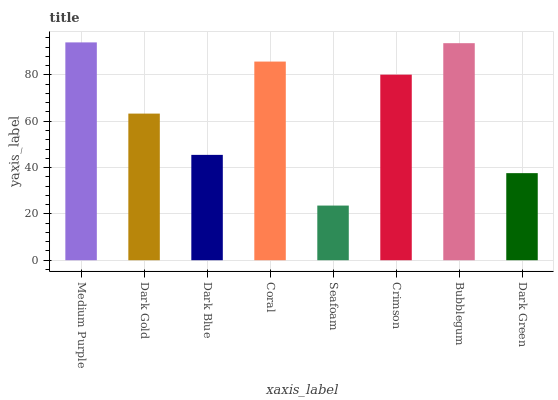Is Seafoam the minimum?
Answer yes or no. Yes. Is Medium Purple the maximum?
Answer yes or no. Yes. Is Dark Gold the minimum?
Answer yes or no. No. Is Dark Gold the maximum?
Answer yes or no. No. Is Medium Purple greater than Dark Gold?
Answer yes or no. Yes. Is Dark Gold less than Medium Purple?
Answer yes or no. Yes. Is Dark Gold greater than Medium Purple?
Answer yes or no. No. Is Medium Purple less than Dark Gold?
Answer yes or no. No. Is Crimson the high median?
Answer yes or no. Yes. Is Dark Gold the low median?
Answer yes or no. Yes. Is Bubblegum the high median?
Answer yes or no. No. Is Coral the low median?
Answer yes or no. No. 